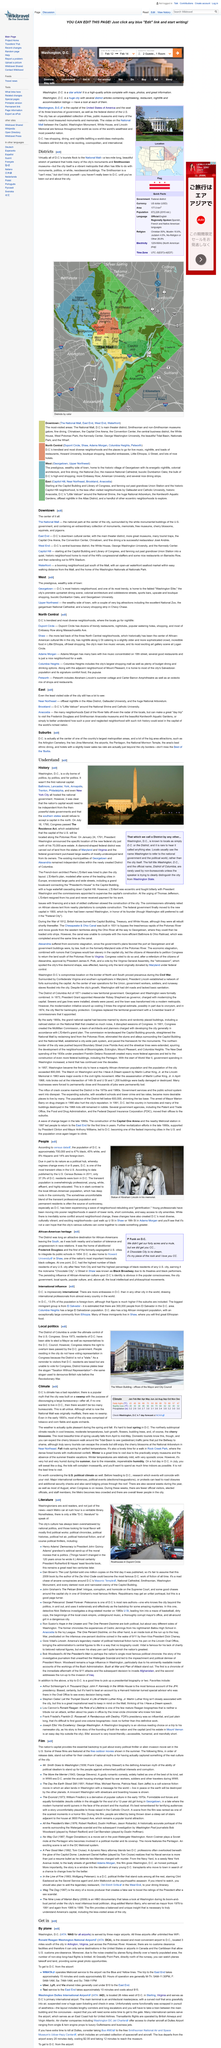Indicate a few pertinent items in this graphic. D.C. is one of the most transient cities in the U.S. due to its status as a political hub where regimes change every 4 or 8 years. Washington, D.C. is one of the most transient cities in the United States. The above image depicts the Statue of Abraham Lincoln in his memorial, showcasing his likeness and stature in a prominent location. 